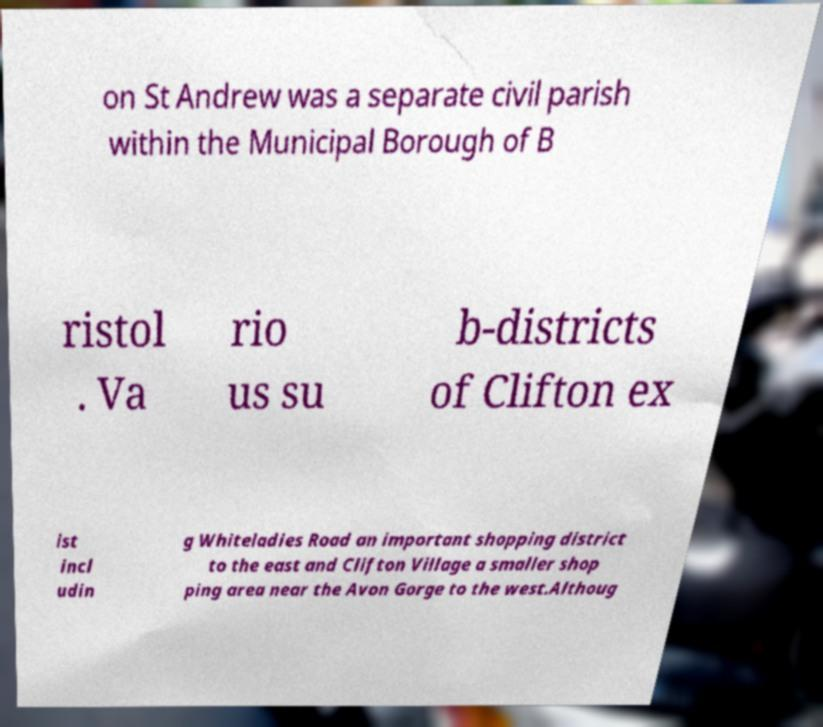What messages or text are displayed in this image? I need them in a readable, typed format. on St Andrew was a separate civil parish within the Municipal Borough of B ristol . Va rio us su b-districts of Clifton ex ist incl udin g Whiteladies Road an important shopping district to the east and Clifton Village a smaller shop ping area near the Avon Gorge to the west.Althoug 